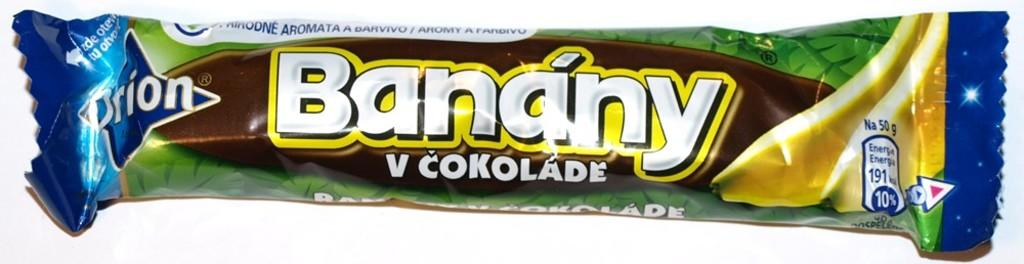What is the main object in the image? There is a chocolate packet in the image. What is the color of the surface the chocolate packet is on? The chocolate packet is on a white surface. What type of furniture is visible in the image? There is no furniture visible in the image; it only features a chocolate packet on a white surface. 